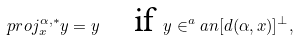<formula> <loc_0><loc_0><loc_500><loc_500>\ p r o j _ { x } ^ { \alpha , \ast } y = y \quad \text {if } y \in ^ { a } a n [ d ( \alpha , x ) ] ^ { \perp } ,</formula> 